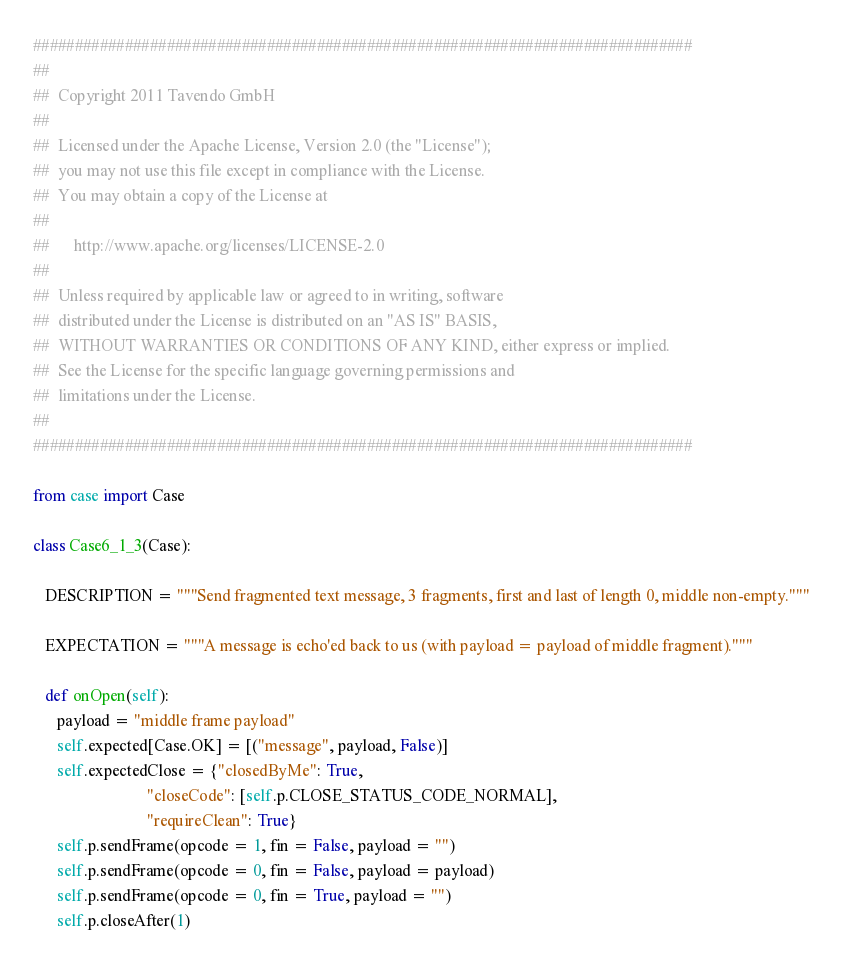<code> <loc_0><loc_0><loc_500><loc_500><_Python_>###############################################################################
##
##  Copyright 2011 Tavendo GmbH
##
##  Licensed under the Apache License, Version 2.0 (the "License");
##  you may not use this file except in compliance with the License.
##  You may obtain a copy of the License at
##
##      http://www.apache.org/licenses/LICENSE-2.0
##
##  Unless required by applicable law or agreed to in writing, software
##  distributed under the License is distributed on an "AS IS" BASIS,
##  WITHOUT WARRANTIES OR CONDITIONS OF ANY KIND, either express or implied.
##  See the License for the specific language governing permissions and
##  limitations under the License.
##
###############################################################################

from case import Case

class Case6_1_3(Case):

   DESCRIPTION = """Send fragmented text message, 3 fragments, first and last of length 0, middle non-empty."""

   EXPECTATION = """A message is echo'ed back to us (with payload = payload of middle fragment)."""

   def onOpen(self):
      payload = "middle frame payload"
      self.expected[Case.OK] = [("message", payload, False)]
      self.expectedClose = {"closedByMe": True,
                            "closeCode": [self.p.CLOSE_STATUS_CODE_NORMAL],
                            "requireClean": True}
      self.p.sendFrame(opcode = 1, fin = False, payload = "")
      self.p.sendFrame(opcode = 0, fin = False, payload = payload)
      self.p.sendFrame(opcode = 0, fin = True, payload = "")
      self.p.closeAfter(1)
</code> 